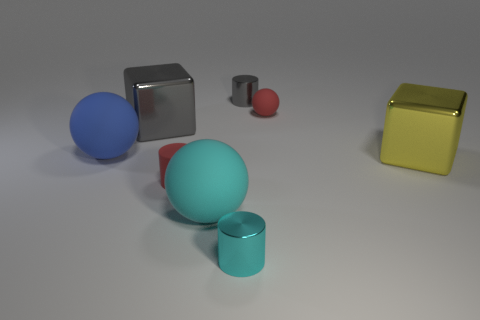What can you infer about the lighting in the scene? The shadows of the objects suggest a single light source, likely positioned above and to the right of the scene, giving it a calm and soft ambiance. The reflections on the smooth and metallic surfaces of the objects indicate the light is bright and intense, though diffused across the area. 